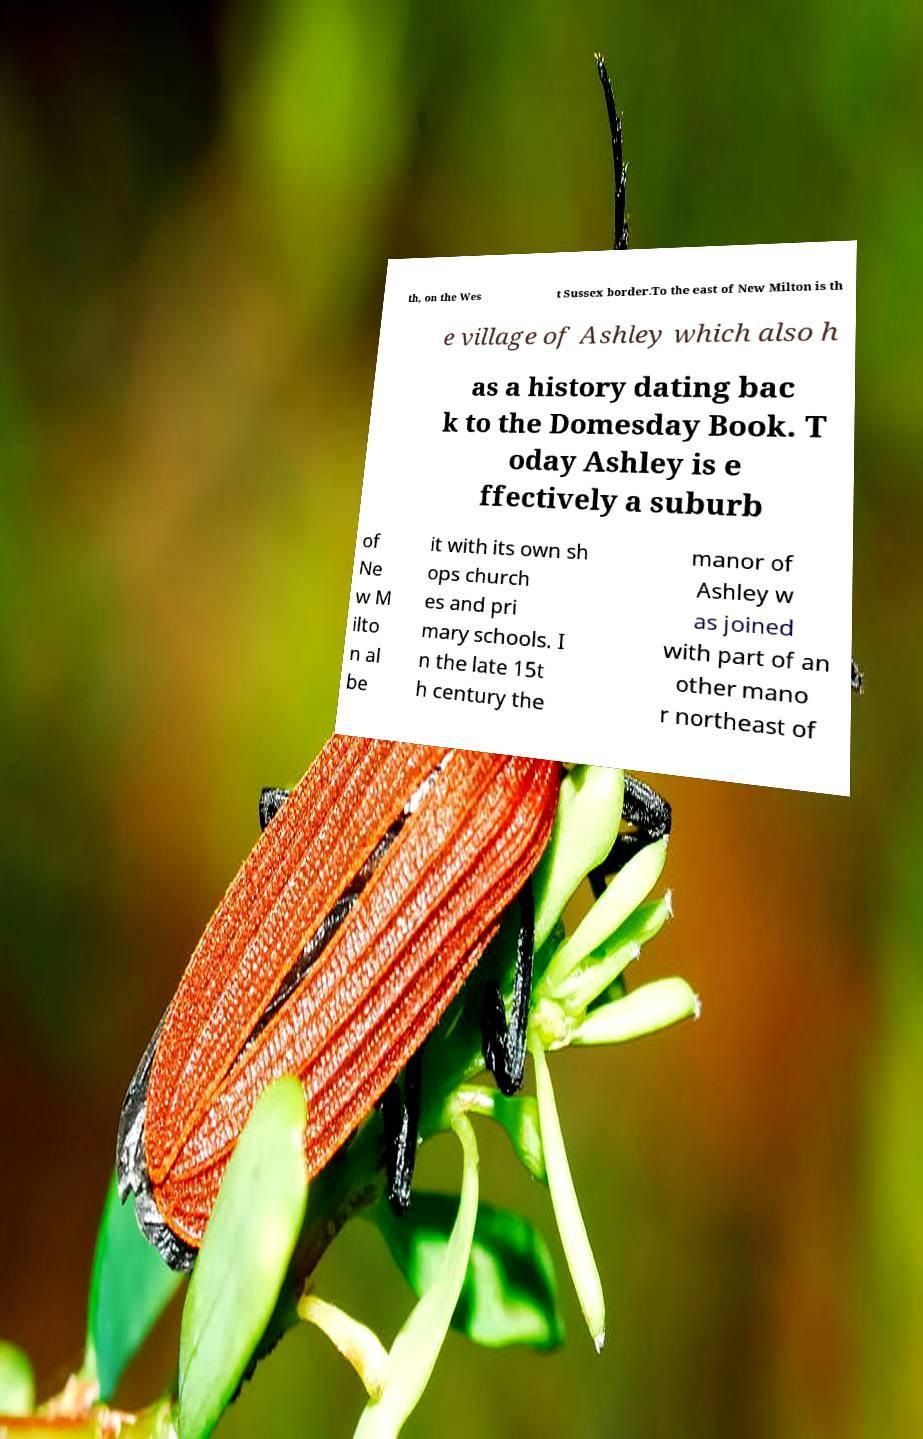I need the written content from this picture converted into text. Can you do that? th, on the Wes t Sussex border.To the east of New Milton is th e village of Ashley which also h as a history dating bac k to the Domesday Book. T oday Ashley is e ffectively a suburb of Ne w M ilto n al be it with its own sh ops church es and pri mary schools. I n the late 15t h century the manor of Ashley w as joined with part of an other mano r northeast of 